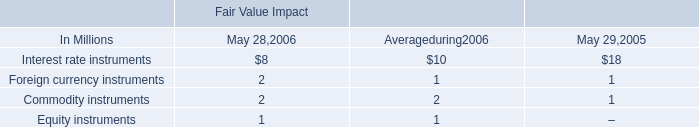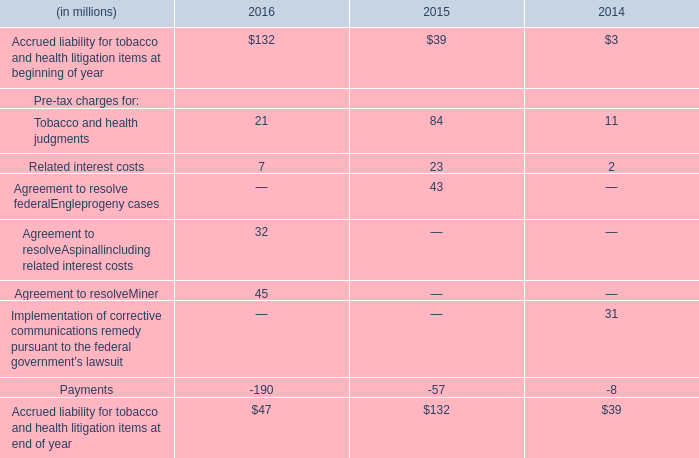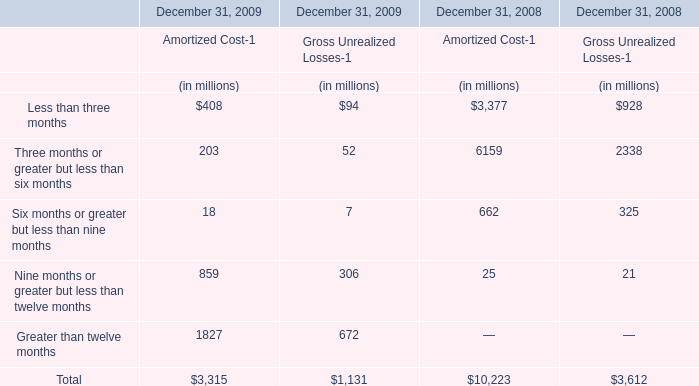In what year is Three months or greater but less than six months positive? 
Answer: 2008 2009. 